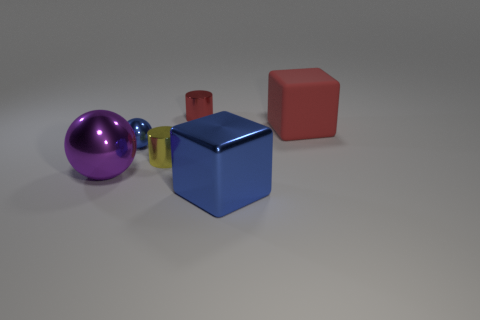Add 1 blue blocks. How many objects exist? 7 Subtract all cylinders. How many objects are left? 4 Add 3 big objects. How many big objects exist? 6 Subtract 0 green cubes. How many objects are left? 6 Subtract all purple matte spheres. Subtract all big matte cubes. How many objects are left? 5 Add 1 blue balls. How many blue balls are left? 2 